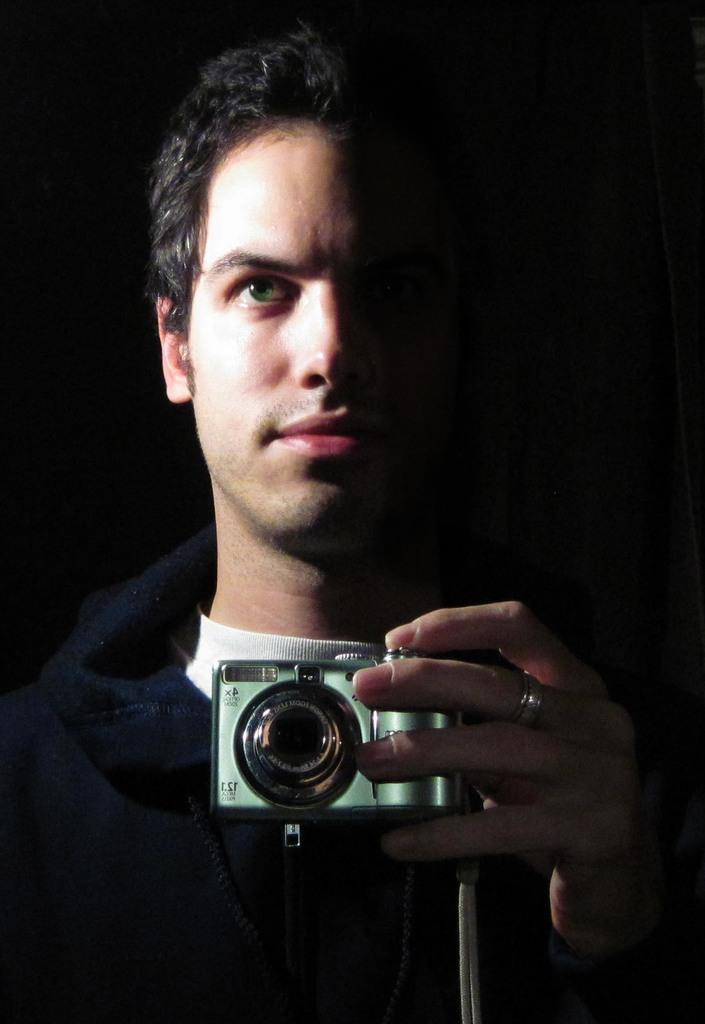What is the main subject of the image? There is a person in the image. What is the person doing in the image? The person is standing. What is the person holding in his hand? The person is holding a camera in his hand. What is the person wearing in the image? The person is wearing a blue and white t-shirt. What accessory can be seen on the person's hand? The person has a ring on his middle finger. What is the person's father doing in the image? There is no information about the person's father in the image. Is the person in the image a woman? No, the person in the image is not a woman; the facts state that the person is a man. 